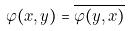<formula> <loc_0><loc_0><loc_500><loc_500>\varphi ( x , y ) = \overline { \varphi ( y , x ) }</formula> 